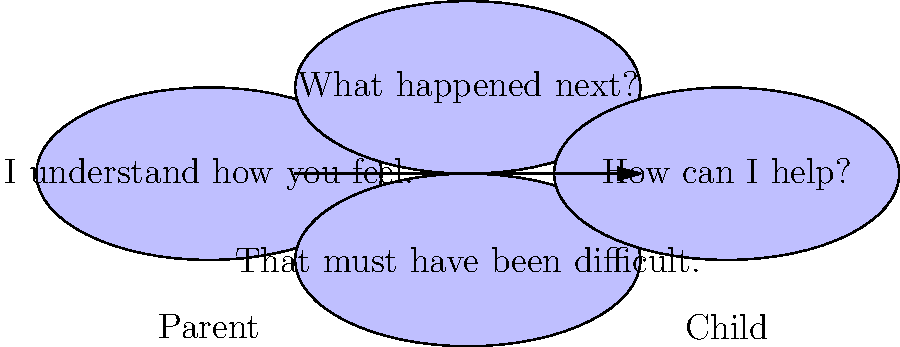In the speech bubble diagram above, which communication technique is most likely to encourage a child to share more about their experiences and emotions? To identify the most effective communication technique for encouraging a child to share more, let's analyze each speech bubble:

1. "I understand how you feel." - This is an empathetic statement, which is good for building rapport, but it doesn't directly encourage further sharing.

2. "What happened next?" - This is an open-ended question that invites the child to continue their story, encouraging them to share more details about their experience.

3. "That must have been difficult." - This is another empathetic statement, acknowledging the child's feelings, but it doesn't explicitly invite further sharing.

4. "How can I help?" - This is a supportive question, but it may shift the focus to problem-solving rather than encouraging the child to continue sharing their thoughts and feelings.

Among these options, "What happened next?" is the most likely to encourage a child to share more about their experiences and emotions. Open-ended questions prompt the child to elaborate on their story, providing more details and potentially revealing more about their thoughts and feelings in the process.

This approach aligns well with the persona of a parent who values open-minded conversation and understanding, as it demonstrates active listening and genuine interest in the child's perspective.
Answer: "What happened next?" 